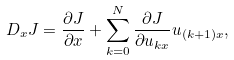<formula> <loc_0><loc_0><loc_500><loc_500>\ D _ { x } J = \frac { \partial J } { \partial x } + \sum _ { k = 0 } ^ { N } \frac { \partial J } { \partial u _ { k x } } u _ { ( k + 1 ) x } ,</formula> 